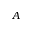Convert formula to latex. <formula><loc_0><loc_0><loc_500><loc_500>A</formula> 